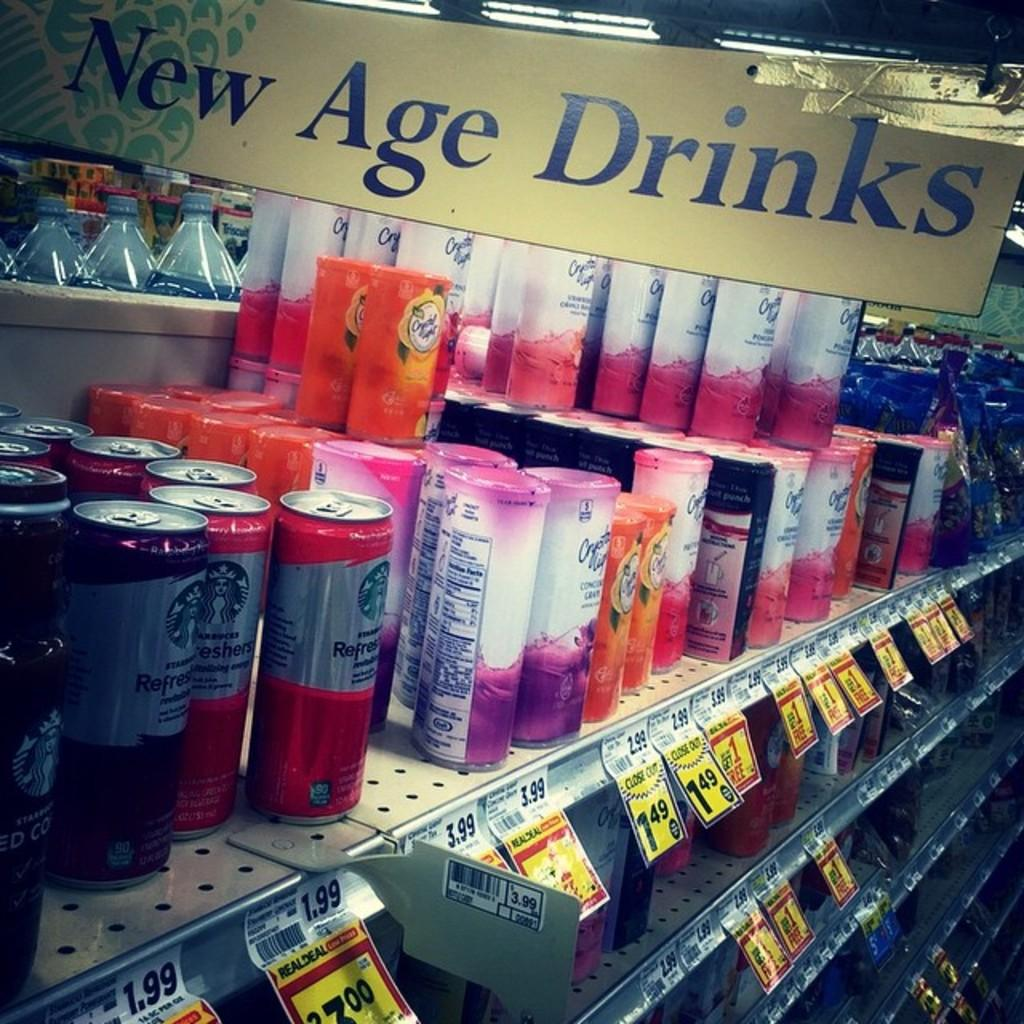<image>
Offer a succinct explanation of the picture presented. some new age drinks that are on a shelf 